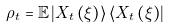<formula> <loc_0><loc_0><loc_500><loc_500>\rho _ { t } = \mathbb { E } \left | X _ { t } \left ( \xi \right ) \right \rangle \left \langle X _ { t } \left ( \xi \right ) \right |</formula> 